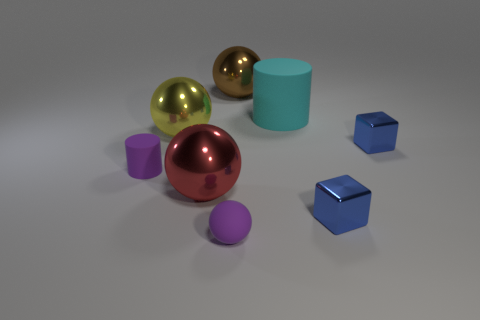What size is the metal object that is in front of the purple rubber cylinder and right of the purple sphere?
Make the answer very short. Small. What number of small things have the same color as the matte sphere?
Keep it short and to the point. 1. What is the small purple sphere made of?
Your response must be concise. Rubber. Is the thing on the left side of the large yellow sphere made of the same material as the large yellow sphere?
Give a very brief answer. No. There is a metal thing that is behind the large matte cylinder; what is its shape?
Your answer should be very brief. Sphere. There is a red ball that is the same size as the brown object; what material is it?
Ensure brevity in your answer.  Metal. How many things are either shiny spheres on the left side of the brown thing or matte things to the right of the large brown object?
Make the answer very short. 3. The purple sphere that is the same material as the small purple cylinder is what size?
Provide a succinct answer. Small. What number of metallic things are either green cylinders or small blue things?
Keep it short and to the point. 2. The yellow metallic object is what size?
Offer a very short reply. Large. 